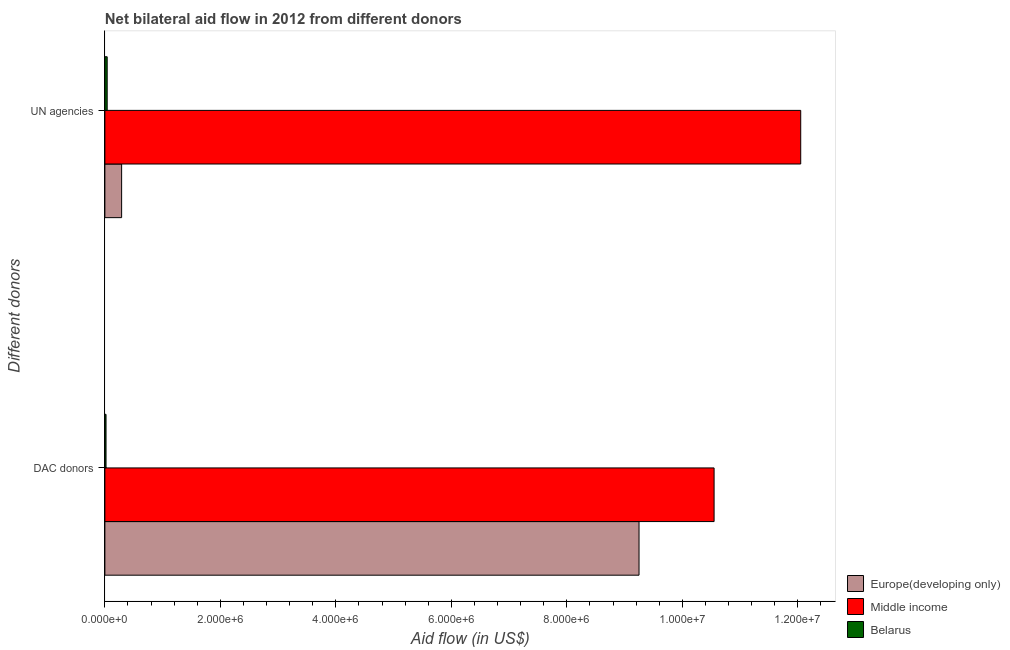How many different coloured bars are there?
Offer a terse response. 3. How many groups of bars are there?
Make the answer very short. 2. Are the number of bars on each tick of the Y-axis equal?
Provide a short and direct response. Yes. How many bars are there on the 1st tick from the top?
Offer a very short reply. 3. What is the label of the 2nd group of bars from the top?
Your answer should be compact. DAC donors. What is the aid flow from dac donors in Middle income?
Provide a short and direct response. 1.06e+07. Across all countries, what is the maximum aid flow from dac donors?
Your answer should be very brief. 1.06e+07. Across all countries, what is the minimum aid flow from dac donors?
Your answer should be compact. 2.00e+04. In which country was the aid flow from dac donors minimum?
Your response must be concise. Belarus. What is the total aid flow from dac donors in the graph?
Give a very brief answer. 1.98e+07. What is the difference between the aid flow from dac donors in Belarus and that in Middle income?
Ensure brevity in your answer.  -1.05e+07. What is the difference between the aid flow from un agencies in Europe(developing only) and the aid flow from dac donors in Middle income?
Your answer should be very brief. -1.03e+07. What is the average aid flow from un agencies per country?
Offer a terse response. 4.13e+06. What is the difference between the aid flow from dac donors and aid flow from un agencies in Belarus?
Ensure brevity in your answer.  -2.00e+04. What is the ratio of the aid flow from dac donors in Middle income to that in Europe(developing only)?
Provide a succinct answer. 1.14. In how many countries, is the aid flow from un agencies greater than the average aid flow from un agencies taken over all countries?
Offer a terse response. 1. What does the 3rd bar from the top in UN agencies represents?
Provide a short and direct response. Europe(developing only). What does the 2nd bar from the bottom in DAC donors represents?
Your answer should be very brief. Middle income. Are all the bars in the graph horizontal?
Your response must be concise. Yes. How many countries are there in the graph?
Provide a succinct answer. 3. Does the graph contain any zero values?
Give a very brief answer. No. Where does the legend appear in the graph?
Provide a short and direct response. Bottom right. How many legend labels are there?
Offer a very short reply. 3. How are the legend labels stacked?
Offer a very short reply. Vertical. What is the title of the graph?
Give a very brief answer. Net bilateral aid flow in 2012 from different donors. What is the label or title of the X-axis?
Offer a very short reply. Aid flow (in US$). What is the label or title of the Y-axis?
Make the answer very short. Different donors. What is the Aid flow (in US$) of Europe(developing only) in DAC donors?
Make the answer very short. 9.25e+06. What is the Aid flow (in US$) of Middle income in DAC donors?
Your answer should be very brief. 1.06e+07. What is the Aid flow (in US$) of Europe(developing only) in UN agencies?
Your answer should be compact. 2.90e+05. What is the Aid flow (in US$) of Middle income in UN agencies?
Give a very brief answer. 1.20e+07. What is the Aid flow (in US$) in Belarus in UN agencies?
Give a very brief answer. 4.00e+04. Across all Different donors, what is the maximum Aid flow (in US$) in Europe(developing only)?
Offer a very short reply. 9.25e+06. Across all Different donors, what is the maximum Aid flow (in US$) in Middle income?
Offer a terse response. 1.20e+07. Across all Different donors, what is the maximum Aid flow (in US$) of Belarus?
Your answer should be compact. 4.00e+04. Across all Different donors, what is the minimum Aid flow (in US$) of Middle income?
Keep it short and to the point. 1.06e+07. What is the total Aid flow (in US$) in Europe(developing only) in the graph?
Your answer should be very brief. 9.54e+06. What is the total Aid flow (in US$) of Middle income in the graph?
Your answer should be compact. 2.26e+07. What is the total Aid flow (in US$) in Belarus in the graph?
Offer a very short reply. 6.00e+04. What is the difference between the Aid flow (in US$) of Europe(developing only) in DAC donors and that in UN agencies?
Provide a short and direct response. 8.96e+06. What is the difference between the Aid flow (in US$) of Middle income in DAC donors and that in UN agencies?
Your answer should be compact. -1.50e+06. What is the difference between the Aid flow (in US$) in Europe(developing only) in DAC donors and the Aid flow (in US$) in Middle income in UN agencies?
Keep it short and to the point. -2.80e+06. What is the difference between the Aid flow (in US$) in Europe(developing only) in DAC donors and the Aid flow (in US$) in Belarus in UN agencies?
Provide a succinct answer. 9.21e+06. What is the difference between the Aid flow (in US$) in Middle income in DAC donors and the Aid flow (in US$) in Belarus in UN agencies?
Provide a short and direct response. 1.05e+07. What is the average Aid flow (in US$) of Europe(developing only) per Different donors?
Your response must be concise. 4.77e+06. What is the average Aid flow (in US$) of Middle income per Different donors?
Ensure brevity in your answer.  1.13e+07. What is the difference between the Aid flow (in US$) in Europe(developing only) and Aid flow (in US$) in Middle income in DAC donors?
Give a very brief answer. -1.30e+06. What is the difference between the Aid flow (in US$) in Europe(developing only) and Aid flow (in US$) in Belarus in DAC donors?
Provide a succinct answer. 9.23e+06. What is the difference between the Aid flow (in US$) in Middle income and Aid flow (in US$) in Belarus in DAC donors?
Offer a very short reply. 1.05e+07. What is the difference between the Aid flow (in US$) in Europe(developing only) and Aid flow (in US$) in Middle income in UN agencies?
Offer a terse response. -1.18e+07. What is the difference between the Aid flow (in US$) in Europe(developing only) and Aid flow (in US$) in Belarus in UN agencies?
Your response must be concise. 2.50e+05. What is the difference between the Aid flow (in US$) of Middle income and Aid flow (in US$) of Belarus in UN agencies?
Keep it short and to the point. 1.20e+07. What is the ratio of the Aid flow (in US$) in Europe(developing only) in DAC donors to that in UN agencies?
Keep it short and to the point. 31.9. What is the ratio of the Aid flow (in US$) of Middle income in DAC donors to that in UN agencies?
Provide a short and direct response. 0.88. What is the ratio of the Aid flow (in US$) in Belarus in DAC donors to that in UN agencies?
Your answer should be compact. 0.5. What is the difference between the highest and the second highest Aid flow (in US$) of Europe(developing only)?
Offer a terse response. 8.96e+06. What is the difference between the highest and the second highest Aid flow (in US$) in Middle income?
Keep it short and to the point. 1.50e+06. What is the difference between the highest and the lowest Aid flow (in US$) in Europe(developing only)?
Your answer should be compact. 8.96e+06. What is the difference between the highest and the lowest Aid flow (in US$) in Middle income?
Keep it short and to the point. 1.50e+06. What is the difference between the highest and the lowest Aid flow (in US$) of Belarus?
Your answer should be compact. 2.00e+04. 